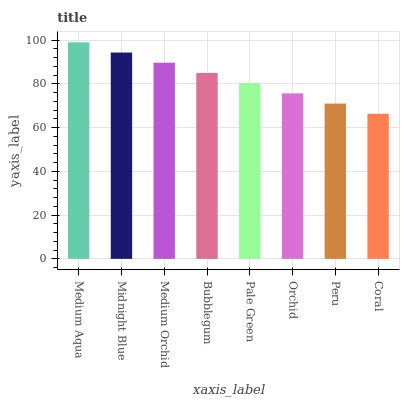Is Midnight Blue the minimum?
Answer yes or no. No. Is Midnight Blue the maximum?
Answer yes or no. No. Is Medium Aqua greater than Midnight Blue?
Answer yes or no. Yes. Is Midnight Blue less than Medium Aqua?
Answer yes or no. Yes. Is Midnight Blue greater than Medium Aqua?
Answer yes or no. No. Is Medium Aqua less than Midnight Blue?
Answer yes or no. No. Is Bubblegum the high median?
Answer yes or no. Yes. Is Pale Green the low median?
Answer yes or no. Yes. Is Medium Aqua the high median?
Answer yes or no. No. Is Peru the low median?
Answer yes or no. No. 